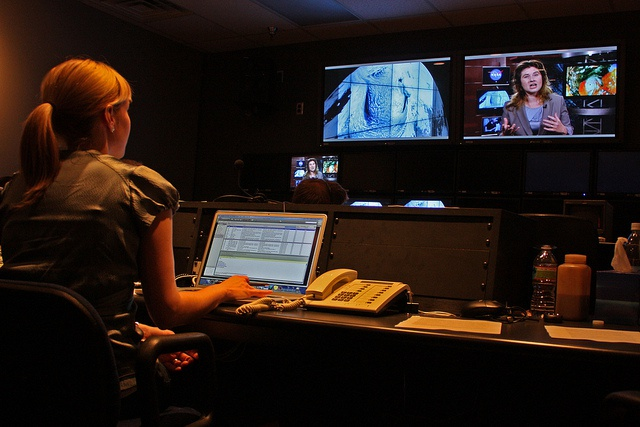Describe the objects in this image and their specific colors. I can see people in maroon, black, brown, and red tones, chair in maroon, black, and brown tones, tv in maroon, black, purple, and gray tones, tv in maroon, black, lightblue, and blue tones, and laptop in maroon, darkgray, and gray tones in this image. 